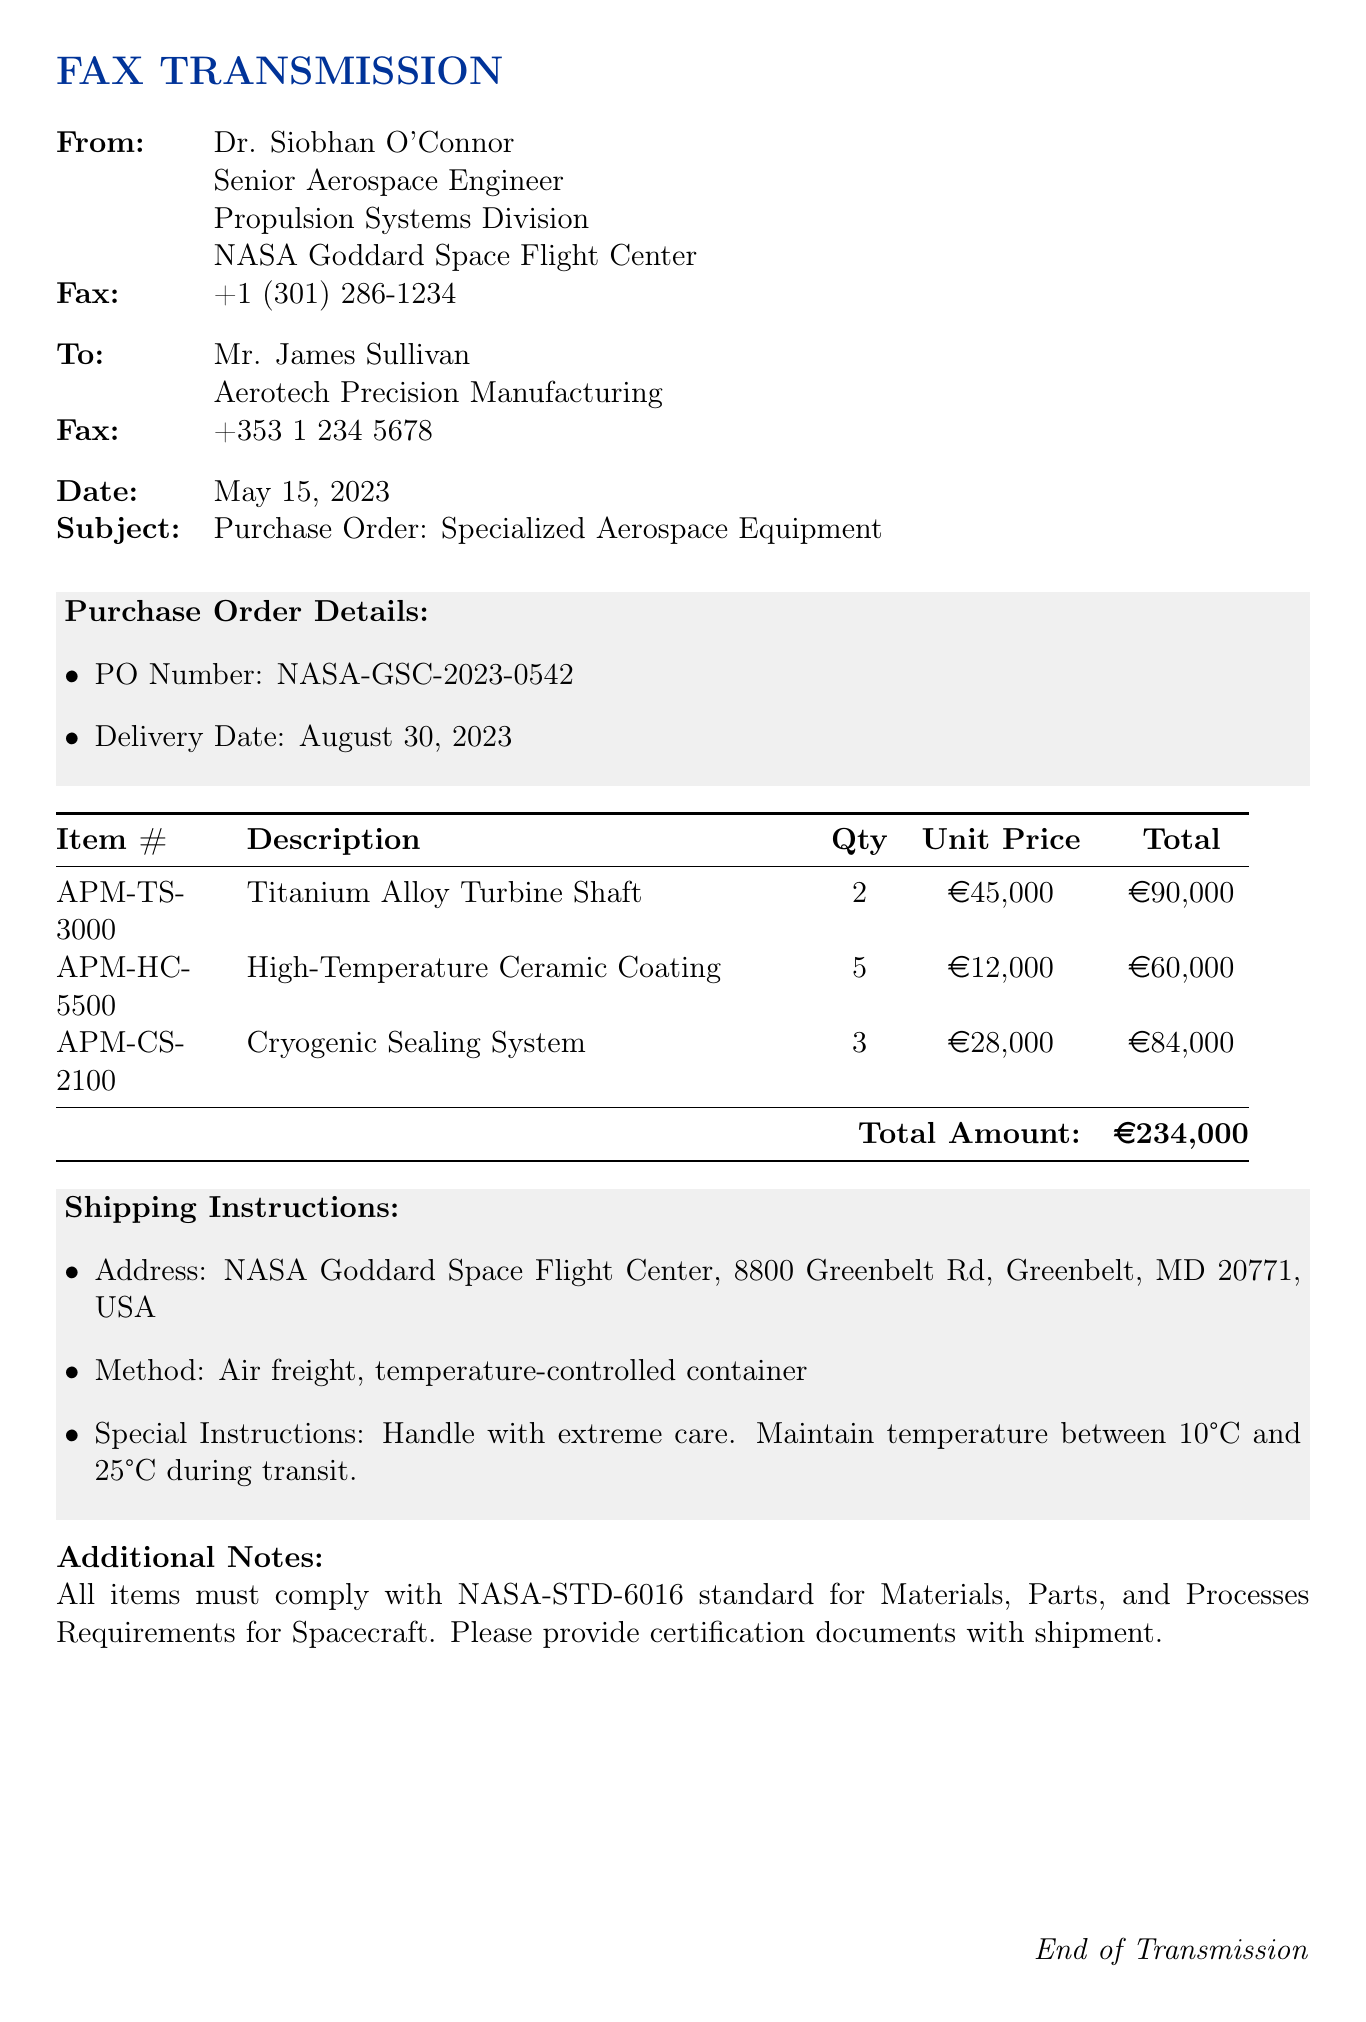what is the PO Number? The PO Number is explicitly mentioned in the purchase order details section of the document.
Answer: NASA-GSC-2023-0542 what is the total amount of the purchase order? The total amount is the final sum listed right before the end of the itemized list in the document.
Answer: €234,000 how many Titanium Alloy Turbine Shafts are ordered? The quantity of Titanium Alloy Turbine Shafts is specified in the itemized list's quantity column.
Answer: 2 when is the delivery date? The delivery date is stated in the purchase order details section of the document.
Answer: August 30, 2023 who is the recipient of the fax? The recipient is clearly indicated at the beginning of the document where the 'To' section is located.
Answer: Mr. James Sullivan what are the shipping instructions method? The method of shipping is found in the shipping instructions section.
Answer: Air freight, temperature-controlled container how many units of High-Temperature Ceramic Coating are being ordered? The number of units ordered for the High-Temperature Ceramic Coating can be found in the itemized list under the 'Qty' column.
Answer: 5 what special handling instruction is provided for the shipment? The special handling instructions are listed in the shipping instructions section of the document.
Answer: Handle with extreme care 